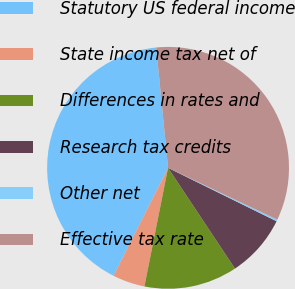Convert chart to OTSL. <chart><loc_0><loc_0><loc_500><loc_500><pie_chart><fcel>Statutory US federal income<fcel>State income tax net of<fcel>Differences in rates and<fcel>Research tax credits<fcel>Other net<fcel>Effective tax rate<nl><fcel>40.99%<fcel>4.31%<fcel>12.46%<fcel>8.39%<fcel>0.23%<fcel>33.61%<nl></chart> 